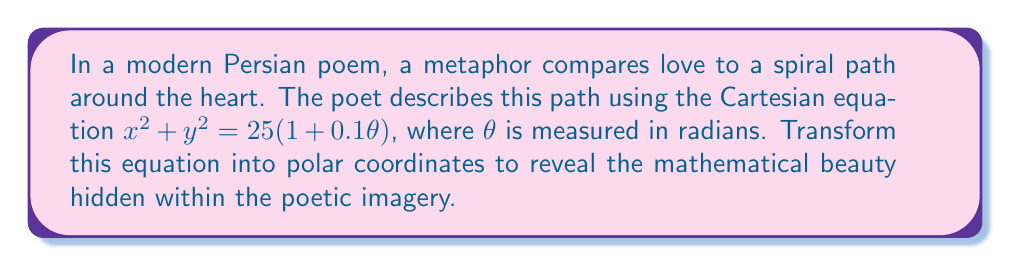Can you solve this math problem? To transform the given Cartesian equation into polar coordinates, we'll follow these steps:

1) Recall the relationship between Cartesian and polar coordinates:
   $x = r \cos(\theta)$
   $y = r \sin(\theta)$

2) Substitute these into the given equation:
   $(r \cos(\theta))^2 + (r \sin(\theta))^2 = 25(1 + 0.1\theta)$

3) Simplify the left side using the trigonometric identity $\cos^2(\theta) + \sin^2(\theta) = 1$:
   $r^2(\cos^2(\theta) + \sin^2(\theta)) = 25(1 + 0.1\theta)$
   $r^2 \cdot 1 = 25(1 + 0.1\theta)$

4) Simplify further:
   $r^2 = 25(1 + 0.1\theta)$

5) Take the square root of both sides:
   $r = \sqrt{25(1 + 0.1\theta)}$

6) Simplify the right side:
   $r = 5\sqrt{1 + 0.1\theta}$

This final equation represents the spiral path in polar coordinates. The square root and $\theta$ term create the spiral effect, while the constant 5 determines the overall size of the spiral.

In the context of the poem, this equation beautifully captures the idea of love as a growing, expanding force that spirals outward from the heart. As $\theta$ increases (representing time or emotional depth), the radius $r$ grows, symbolizing the expanding nature of love.
Answer: $r = 5\sqrt{1 + 0.1\theta}$ 